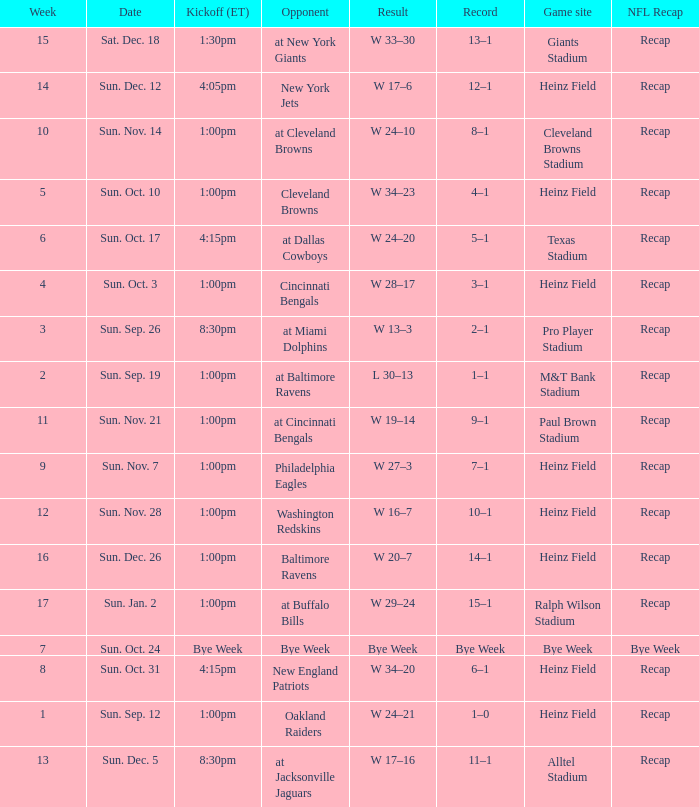Which Kickoff (ET) has a Result of w 34–23? 1:00pm. 